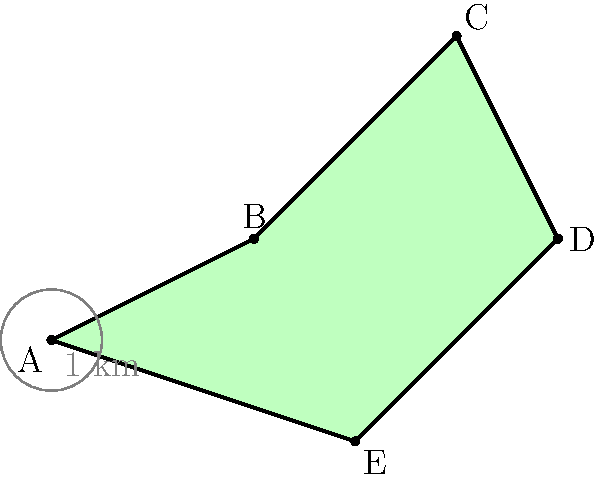Using satellite imagery, you've identified an irregularly shaped territory of interest. The territory is approximated by the polygon ABCDE shown in the image. Given that each grid unit represents 1 km, calculate the area of this territory in square kilometers. Round your answer to the nearest whole number. To calculate the area of this irregular polygon, we can use the Shoelace formula (also known as the surveyor's formula). The steps are as follows:

1) First, we need to identify the coordinates of each point:
   A: (0,0), B: (2,1), C: (4,3), D: (5,1), E: (3,-1)

2) The Shoelace formula for the area of a polygon with vertices $(x_1,y_1), (x_2,y_2), ..., (x_n,y_n)$ is:

   $$Area = \frac{1}{2}|(x_1y_2 + x_2y_3 + ... + x_ny_1) - (y_1x_2 + y_2x_3 + ... + y_nx_1)|$$

3) Applying this formula to our polygon:

   $$\begin{align*}
   Area &= \frac{1}{2}|(0\cdot1 + 2\cdot3 + 4\cdot1 + 5\cdot(-1) + 3\cdot0) \\
   &\quad - (0\cdot2 + 1\cdot4 + 3\cdot5 + 1\cdot3 + (-1)\cdot0)|
   \end{align*}$$

4) Simplifying:

   $$\begin{align*}
   Area &= \frac{1}{2}|(0 + 6 + 4 - 5 + 0) - (0 + 4 + 15 + 3 + 0)| \\
   &= \frac{1}{2}|5 - 22| \\
   &= \frac{1}{2}\cdot17 \\
   &= 8.5 \text{ km}^2
   \end{align*}$$

5) Rounding to the nearest whole number: 9 km²
Answer: 9 km² 